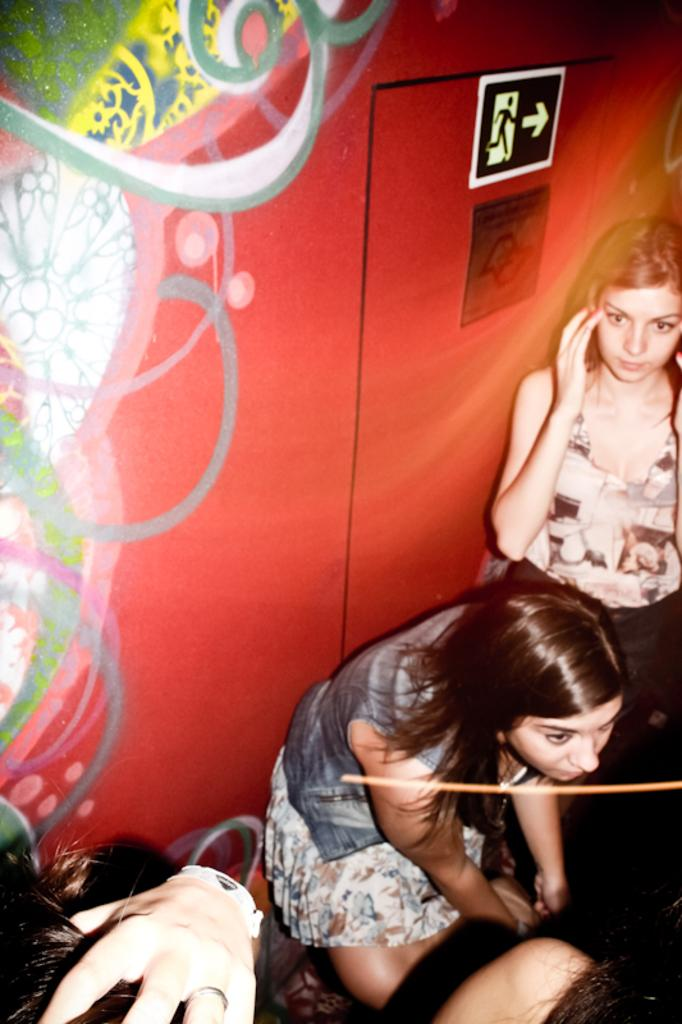How many people are in the image? There is a group of people in the image. Can you describe the clothing of one person in the group? One person in the group is wearing a gray and white color dress. What colors can be seen on the wall in the background of the image? The background of the image includes a wall with red, yellow, green, white, and gray colors. What is the tendency of the wax to rub against the wall in the image? There is no wax present in the image, so it is not possible to determine its tendency to rub against the wall. 